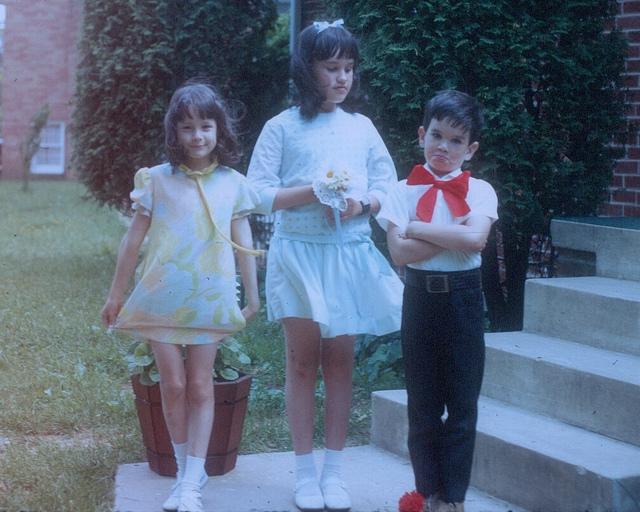How many steps are there?
Quick response, please. 4. IS he wearing a large bow?
Quick response, please. Yes. How many of the kids are wearing dresses?
Give a very brief answer. 2. 